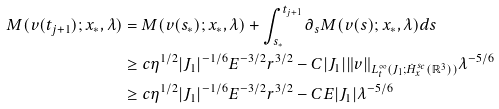<formula> <loc_0><loc_0><loc_500><loc_500>M ( v ( t _ { j + 1 } ) ; x _ { * } , \lambda ) & = M ( v ( s _ { * } ) ; x _ { * } , \lambda ) + \int _ { s _ { * } } ^ { t _ { j + 1 } } \partial _ { s } M ( v ( s ) ; x _ { * } , \lambda ) d s \\ & \geq c \eta ^ { 1 / 2 } | J _ { 1 } | ^ { - 1 / 6 } E ^ { - 3 / 2 } r ^ { 3 / 2 } - C | J _ { 1 } | \| v \| _ { L _ { t } ^ { \infty } ( J _ { 1 } ; \dot { H } _ { x } ^ { s _ { c } } ( \mathbb { R } ^ { 3 } ) ) } \lambda ^ { - 5 / 6 } \\ & \geq c \eta ^ { 1 / 2 } | J _ { 1 } | ^ { - 1 / 6 } E ^ { - 3 / 2 } r ^ { 3 / 2 } - C E | J _ { 1 } | \lambda ^ { - 5 / 6 }</formula> 